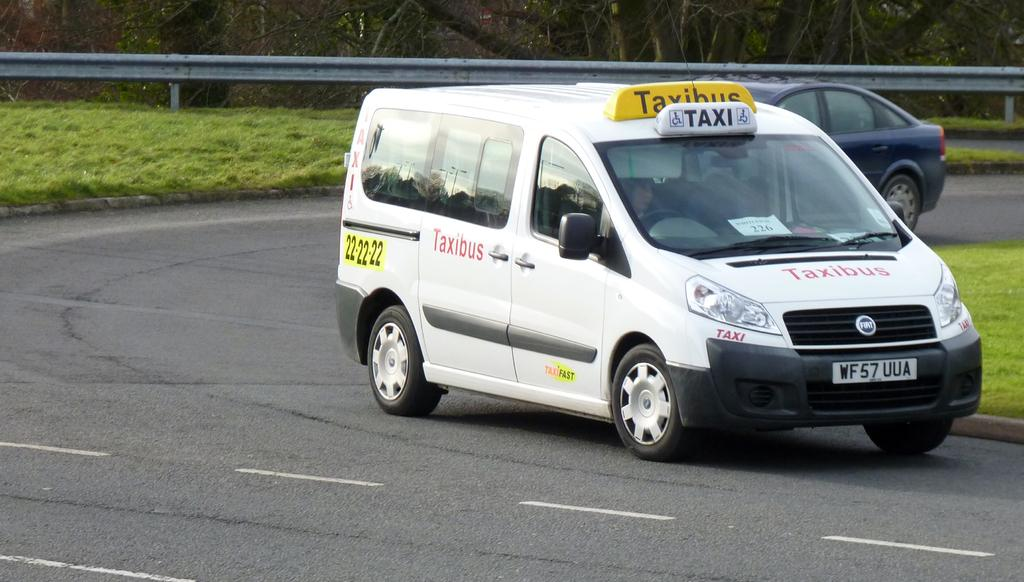How many vehicles can be seen on the road in the image? There are two vehicles on the road in the image. What is the color of one of the vehicles? One vehicle is white in color. What type of vegetation is visible in the background of the image? There is grass and trees in green color visible in the background of the image. What type of fencing can be seen in the background of the image? There is iron fencing in the background of the image. What type of activity is the hook participating in the image? There is no hook present in the image, so it cannot be participating in any activity. 